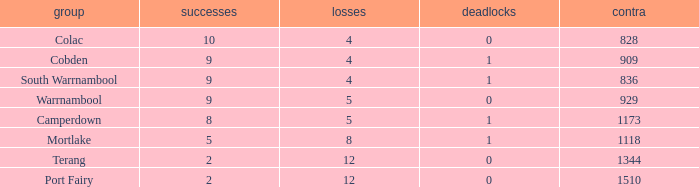What is the average number of draws for losses over 8 and Against values under 1344? None. 